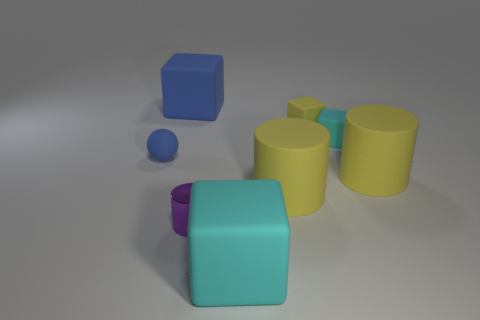Subtract all yellow blocks. How many blocks are left? 3 Subtract all gray blocks. Subtract all brown spheres. How many blocks are left? 4 Add 1 metal blocks. How many objects exist? 9 Subtract all balls. How many objects are left? 7 Add 5 tiny rubber spheres. How many tiny rubber spheres exist? 6 Subtract 0 green balls. How many objects are left? 8 Subtract all large matte objects. Subtract all large blue rubber blocks. How many objects are left? 3 Add 4 purple metal things. How many purple metal things are left? 5 